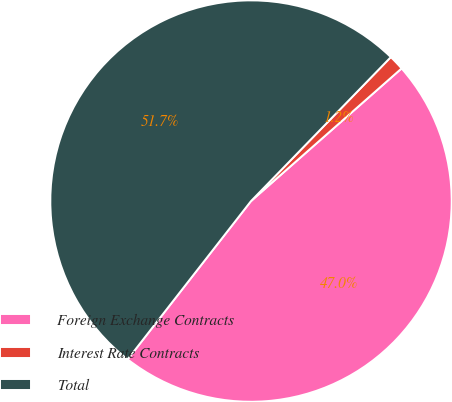Convert chart to OTSL. <chart><loc_0><loc_0><loc_500><loc_500><pie_chart><fcel>Foreign Exchange Contracts<fcel>Interest Rate Contracts<fcel>Total<nl><fcel>47.03%<fcel>1.24%<fcel>51.73%<nl></chart> 